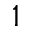<formula> <loc_0><loc_0><loc_500><loc_500>^ { 1 }</formula> 